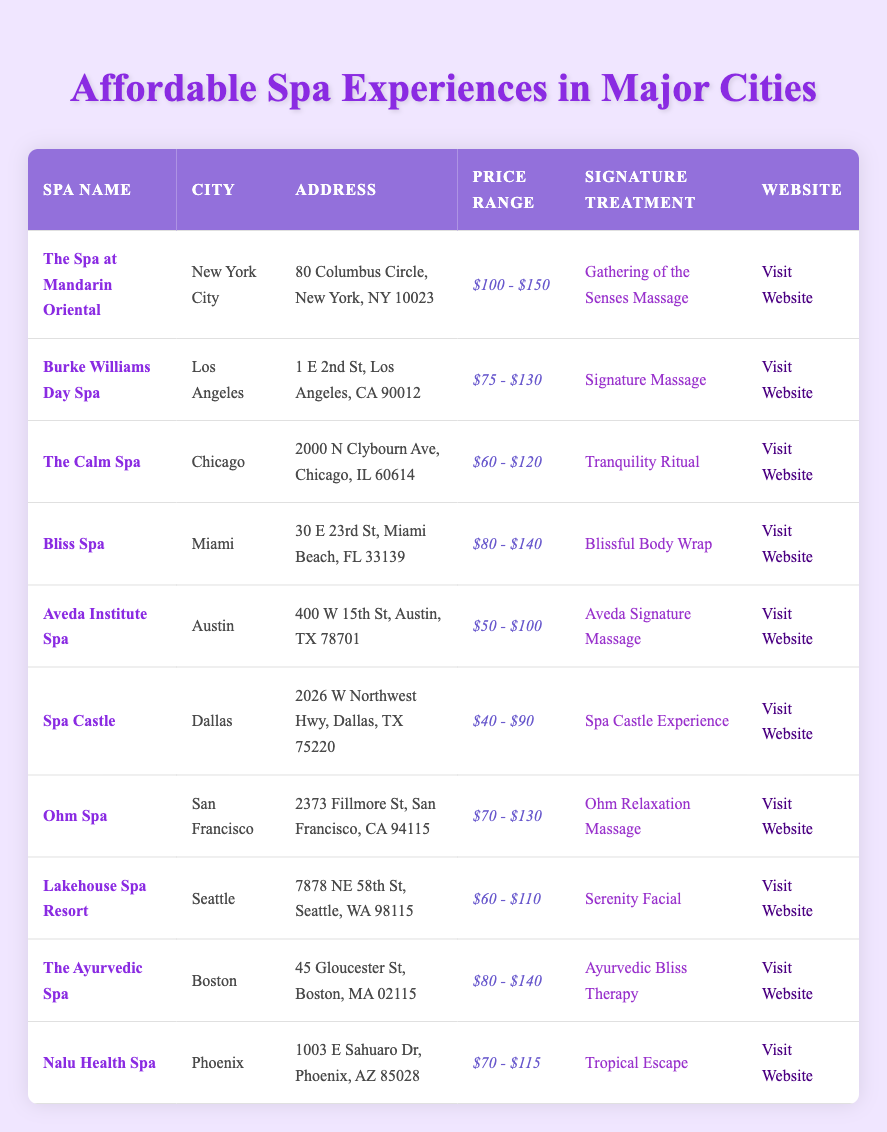What is the signature treatment offered at The Calm Spa? According to the table, The Calm Spa's signature treatment is "Tranquility Ritual," which can be found in the corresponding row for that spa.
Answer: Tranquility Ritual Which city has the spa with the lowest price range? Looking through the price ranges in the table, Spa Castle in Dallas has the lowest price range of "$40 - $90". Therefore, the city with the lowest price range is Dallas.
Answer: Dallas Is the price range for Bliss Spa higher than that of Aveda Institute Spa? The price range for Bliss Spa is "$80 - $140", while for Aveda Institute Spa it is "$50 - $100". Since "$80 - $140" indicates higher values compared to "$50 - $100", it confirms that yes, Bliss Spa’s range is higher.
Answer: Yes What is the average price range of the spas located in cities on the west coast (Los Angeles, San Francisco, and Seattle)? The price ranges are: LA: "$75 - $130", SF: "$70 - $130", Seattle: "$60 - $110". We can take the approximate averages of the price ranges: LA: $102.5, SF: $100, Seattle: $85. So the average of these three averages is (102.5 + 100 + 85) / 3 = $95.83, rounded gives the average range of about $70 - $130.
Answer: $70 - $130 Does Nalu Health Spa offer a treatment that is less expensive than The Ayurvedic Spa? The price range for Nalu Health Spa is "$70 - $115", while The Ayurvedic Spa's price range is "$80 - $140". Since Nalu's minimum price is $70, it is indeed less than Ayurveda's minimum of $80.
Answer: Yes Which spa has a signature treatment called "Ohm Relaxation Massage"? By referencing the table, we can see that the spa offering the "Ohm Relaxation Massage" is Ohm Spa located in San Francisco.
Answer: Ohm Spa What is the total number of spas listed in the table that offer treatments priced over $100? The price ranges that exceed $100 are for The Spa at Mandarin Oriental, Bliss Spa, and The Ayurvedic Spa. Counting each one gives us three spas in total offering treatments priced over $100.
Answer: 3 Which city features the most affordable spa experience based on the listed price ranges? Spa Castle in Dallas offers the most affordable experience with a price range of "$40 - $90". Thus, Dallas is the city with the most affordable spa experience.
Answer: Dallas 